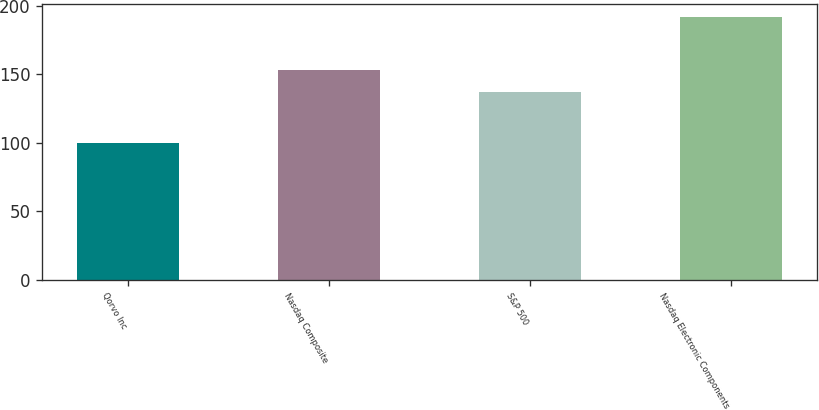Convert chart. <chart><loc_0><loc_0><loc_500><loc_500><bar_chart><fcel>Qorvo Inc<fcel>Nasdaq Composite<fcel>S&P 500<fcel>Nasdaq Electronic Components<nl><fcel>100.07<fcel>153.56<fcel>137.24<fcel>191.99<nl></chart> 